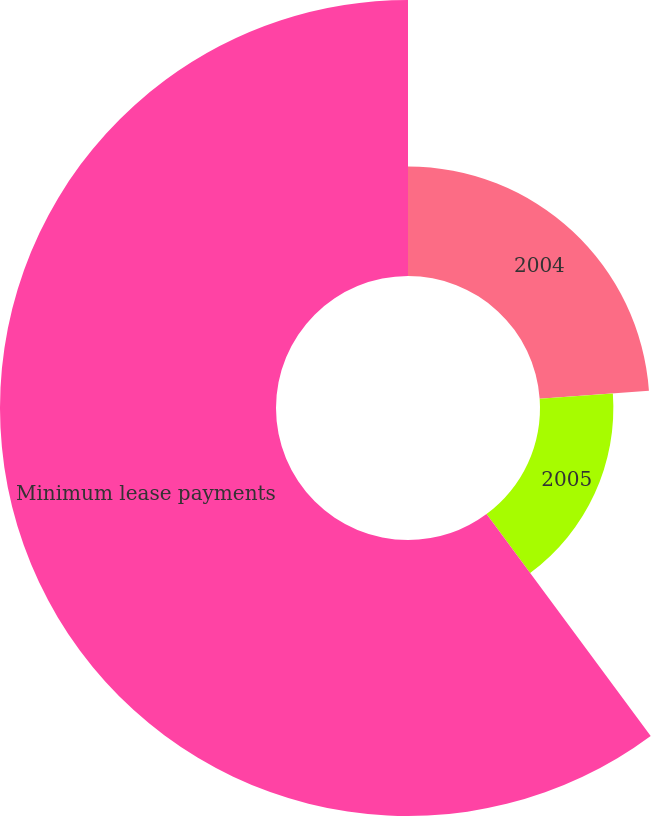<chart> <loc_0><loc_0><loc_500><loc_500><pie_chart><fcel>2004<fcel>2005<fcel>Minimum lease payments<nl><fcel>23.87%<fcel>15.99%<fcel>60.14%<nl></chart> 